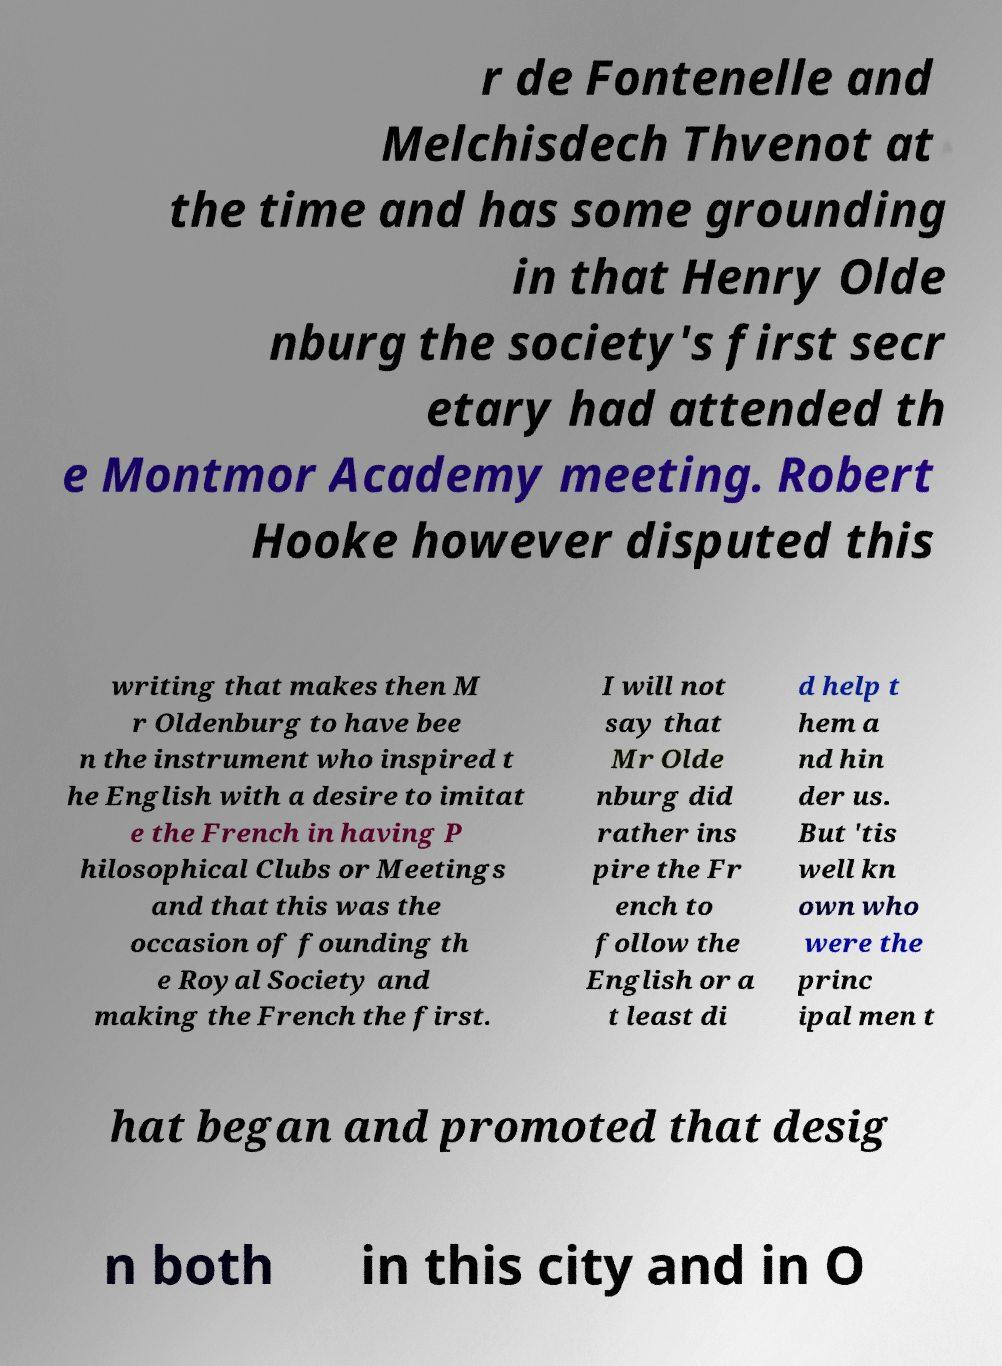Can you read and provide the text displayed in the image?This photo seems to have some interesting text. Can you extract and type it out for me? r de Fontenelle and Melchisdech Thvenot at the time and has some grounding in that Henry Olde nburg the society's first secr etary had attended th e Montmor Academy meeting. Robert Hooke however disputed this writing that makes then M r Oldenburg to have bee n the instrument who inspired t he English with a desire to imitat e the French in having P hilosophical Clubs or Meetings and that this was the occasion of founding th e Royal Society and making the French the first. I will not say that Mr Olde nburg did rather ins pire the Fr ench to follow the English or a t least di d help t hem a nd hin der us. But 'tis well kn own who were the princ ipal men t hat began and promoted that desig n both in this city and in O 